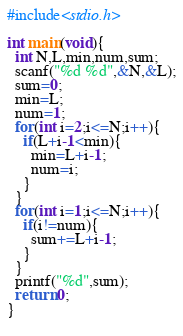<code> <loc_0><loc_0><loc_500><loc_500><_C_>#include<stdio.h>

int main(void){
  int N,L,min,num,sum;
  scanf("%d %d",&N,&L);
  sum=0;
  min=L;
  num=1;
  for(int i=2;i<=N;i++){
    if(L+i-1<min){
      min=L+i-1;
      num=i;
    }
  }
  for(int i=1;i<=N;i++){
    if(i!=num){
      sum+=L+i-1;
    }
  }
  printf("%d",sum);
  return 0;
}
    </code> 